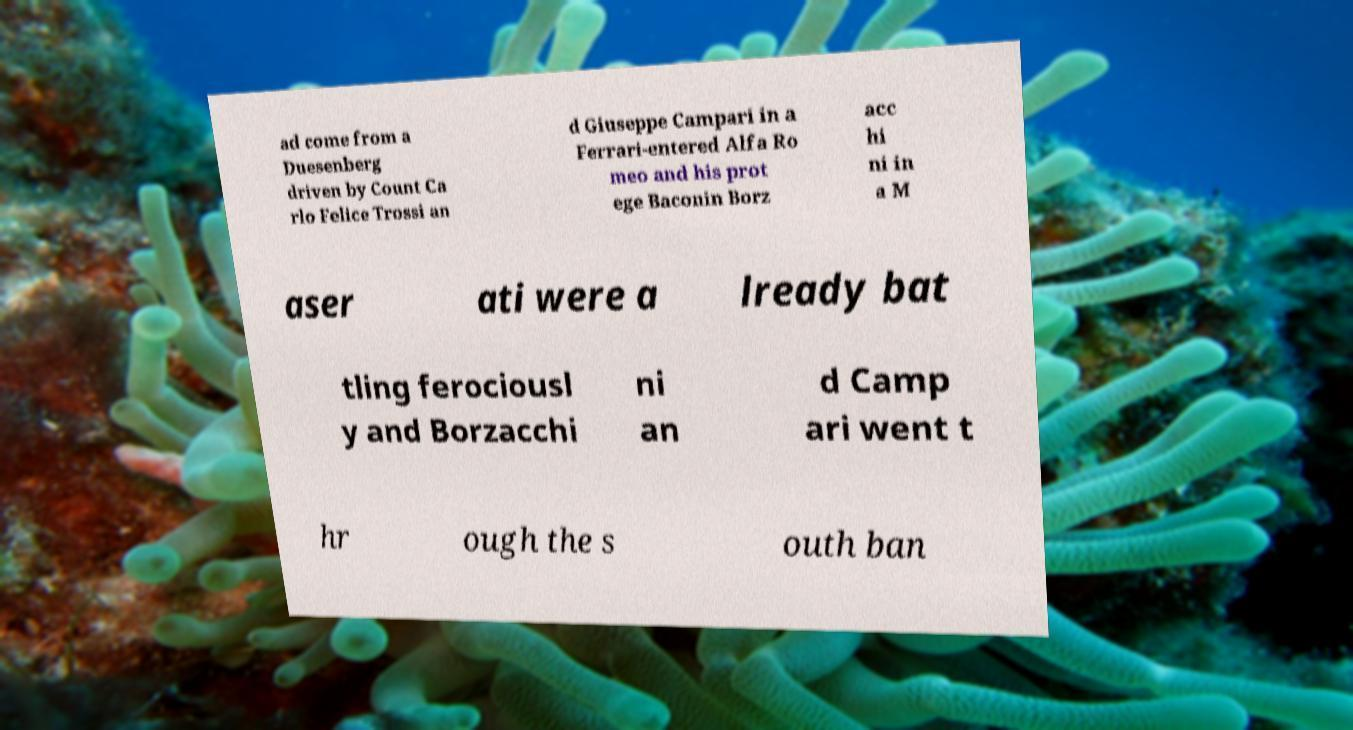There's text embedded in this image that I need extracted. Can you transcribe it verbatim? ad come from a Duesenberg driven by Count Ca rlo Felice Trossi an d Giuseppe Campari in a Ferrari-entered Alfa Ro meo and his prot ege Baconin Borz acc hi ni in a M aser ati were a lready bat tling ferociousl y and Borzacchi ni an d Camp ari went t hr ough the s outh ban 